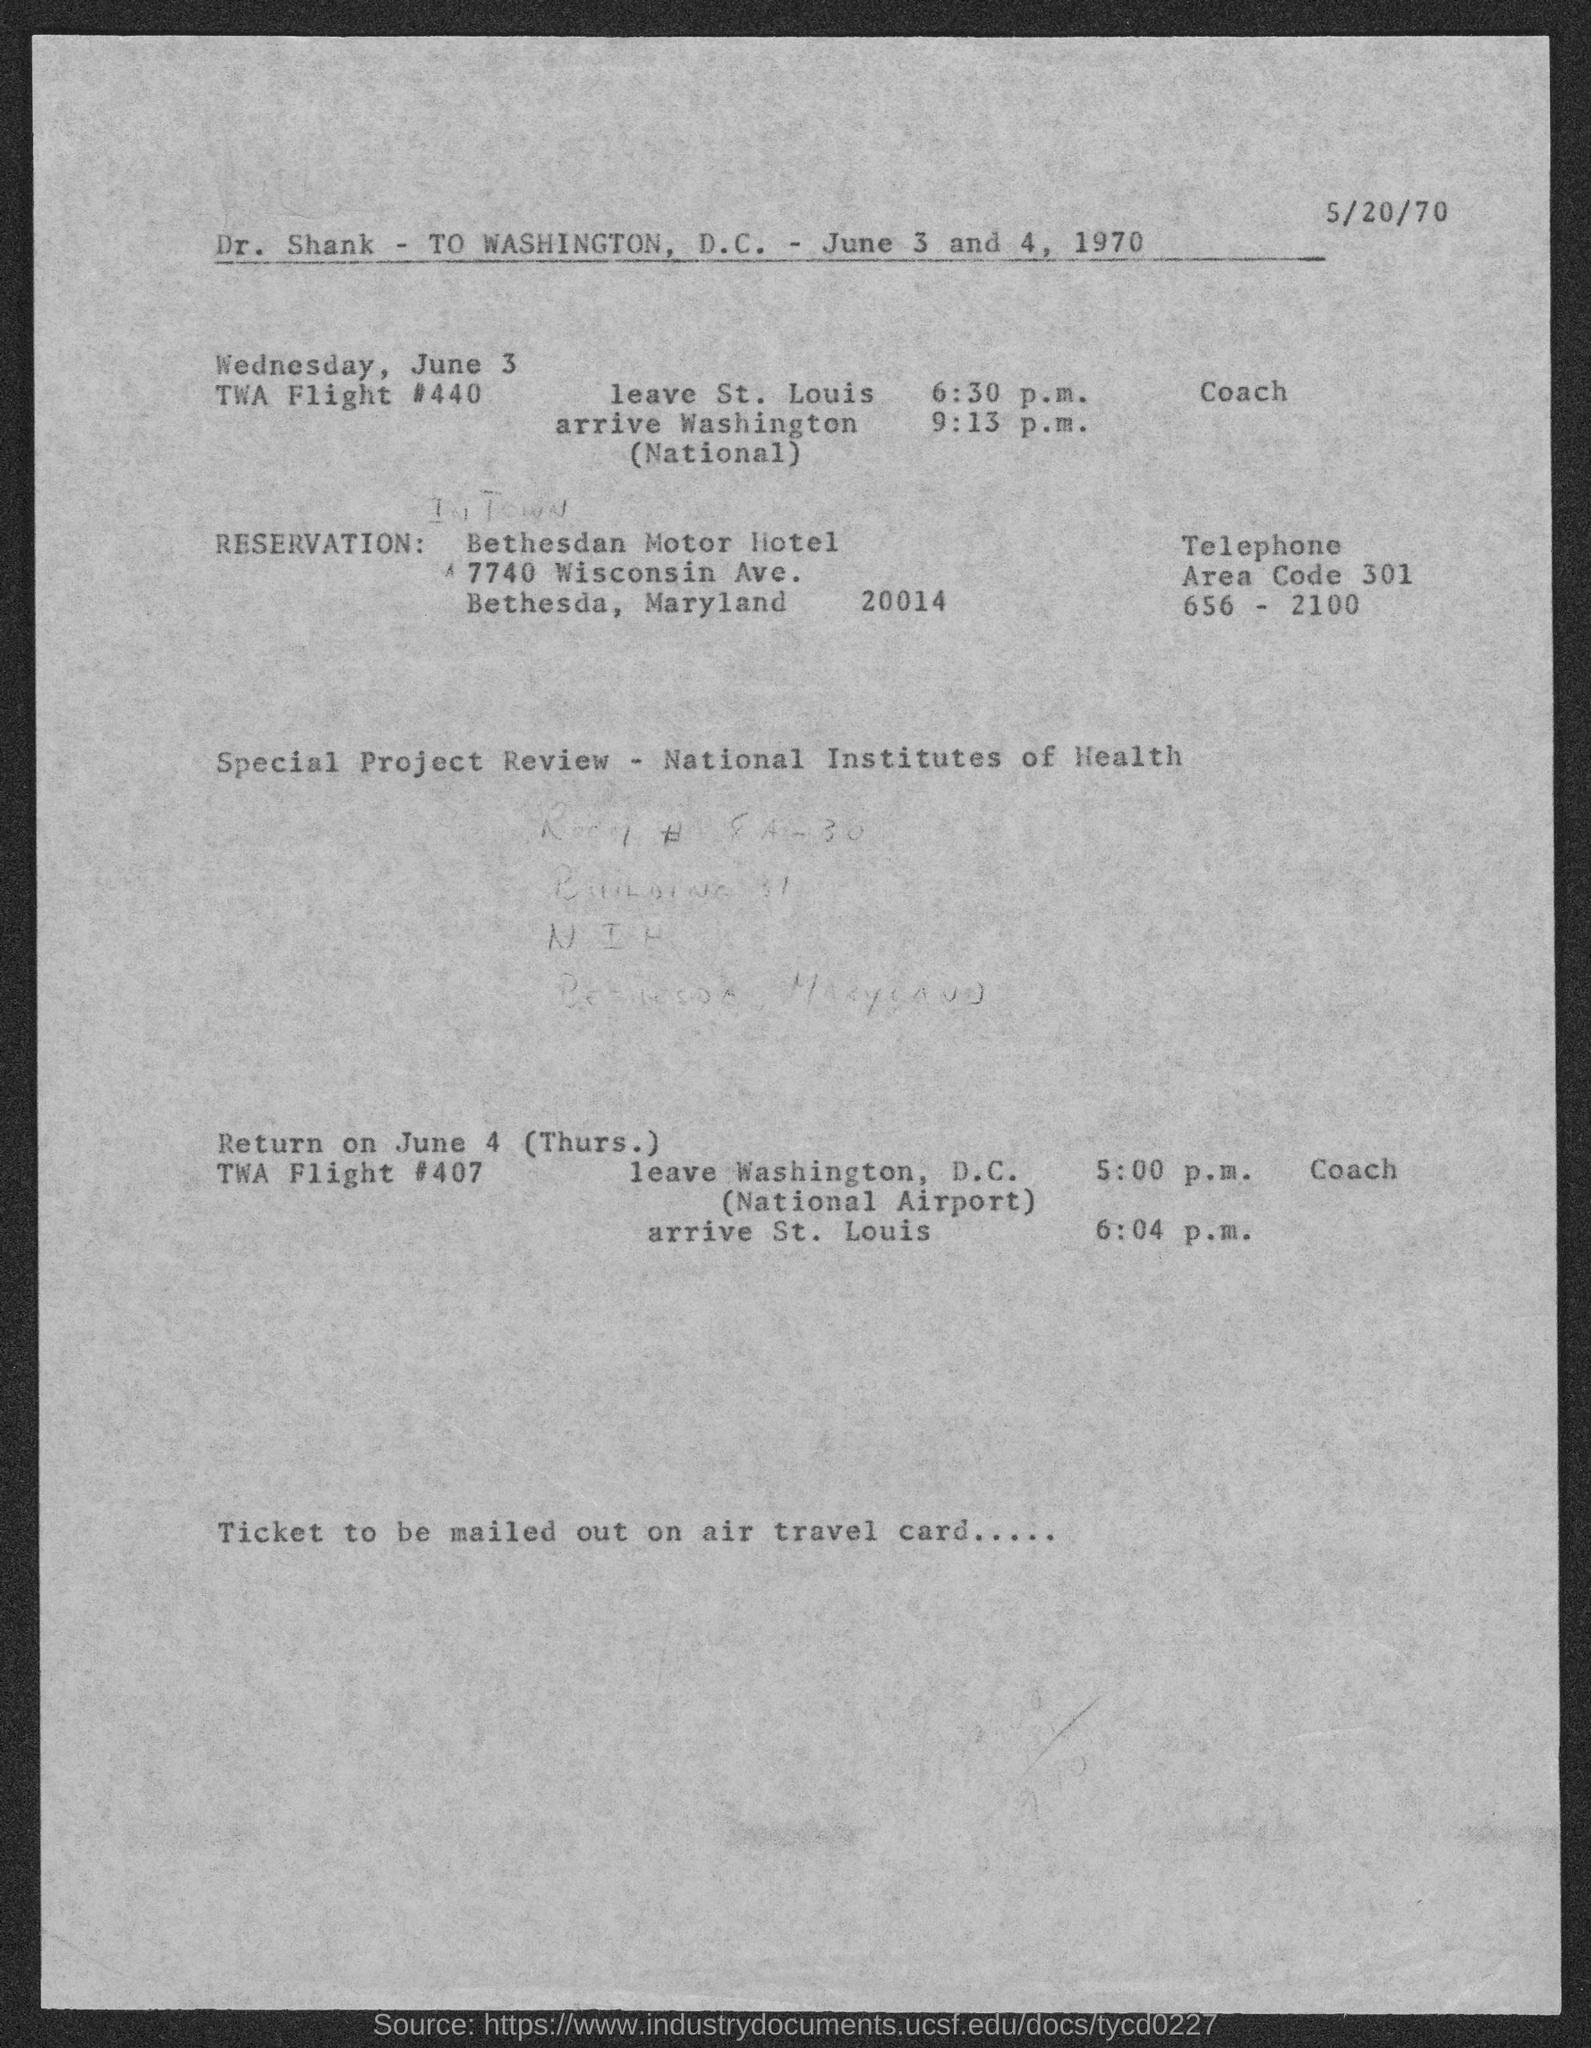Whose name is mentioned in the top of the document?
Provide a succinct answer. Dr. Shank. When is the return flight?
Provide a short and direct response. June 4. At what time return flight leaves Washington, D.C.?
Provide a succinct answer. 5:00 p.m. What is the zipcode of the address given under "reservation"?
Offer a terse response. 20014. 